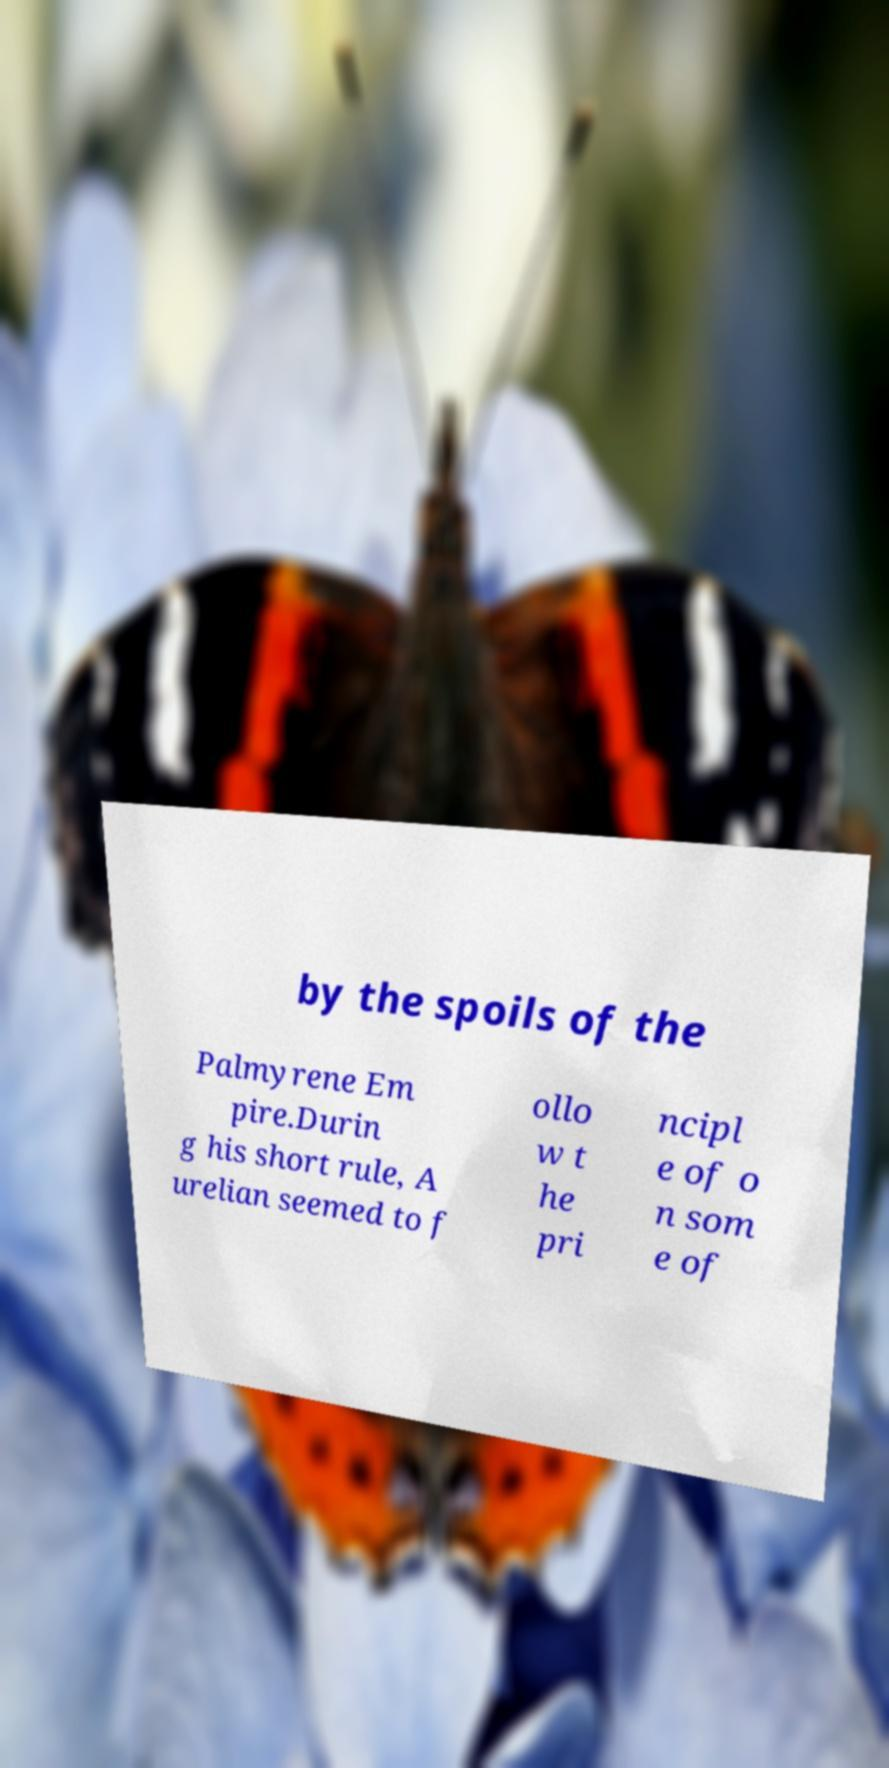For documentation purposes, I need the text within this image transcribed. Could you provide that? by the spoils of the Palmyrene Em pire.Durin g his short rule, A urelian seemed to f ollo w t he pri ncipl e of o n som e of 